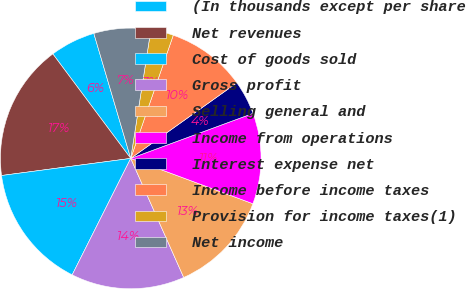Convert chart. <chart><loc_0><loc_0><loc_500><loc_500><pie_chart><fcel>(In thousands except per share<fcel>Net revenues<fcel>Cost of goods sold<fcel>Gross profit<fcel>Selling general and<fcel>Income from operations<fcel>Interest expense net<fcel>Income before income taxes<fcel>Provision for income taxes(1)<fcel>Net income<nl><fcel>5.63%<fcel>16.9%<fcel>15.49%<fcel>14.08%<fcel>12.68%<fcel>11.27%<fcel>4.23%<fcel>9.86%<fcel>2.82%<fcel>7.04%<nl></chart> 